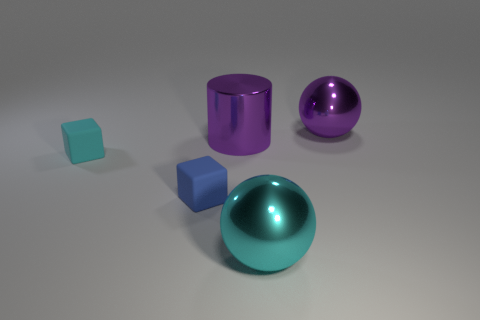Are the objects in the image floating or resting on a surface? The objects in the image are resting on a flat surface, not floating. You can tell because they are casting slight shadows directly beneath them, which would not be present if they were floating. 